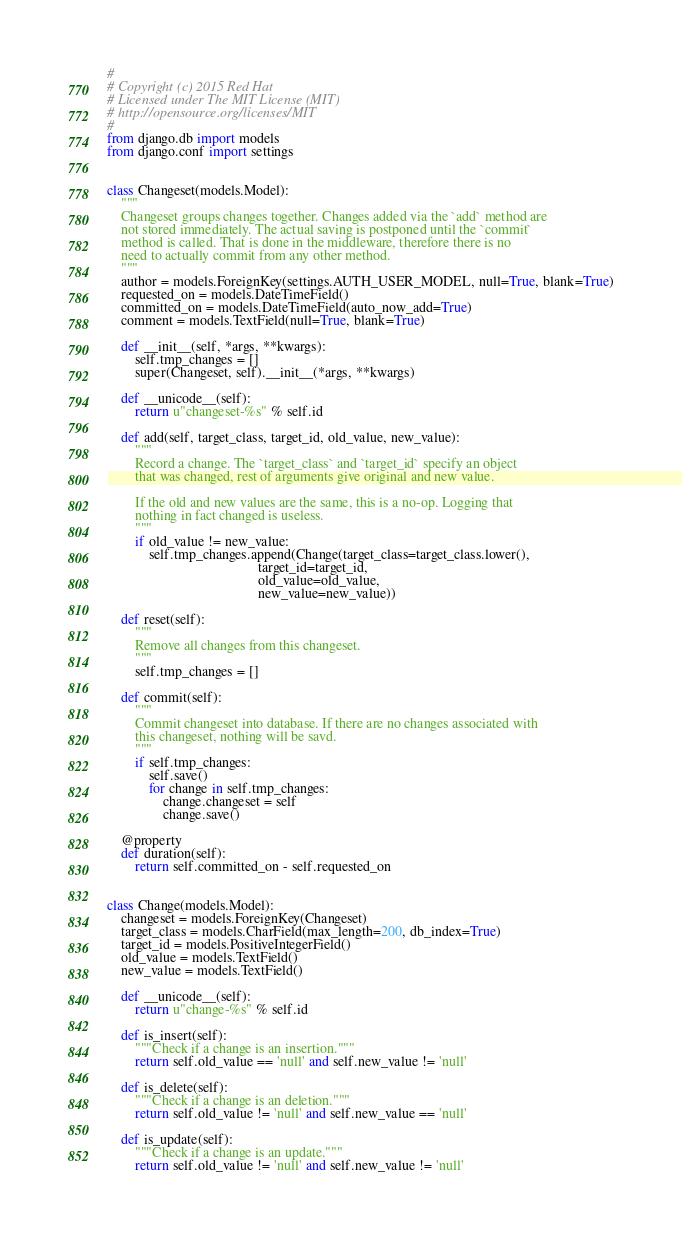<code> <loc_0><loc_0><loc_500><loc_500><_Python_>#
# Copyright (c) 2015 Red Hat
# Licensed under The MIT License (MIT)
# http://opensource.org/licenses/MIT
#
from django.db import models
from django.conf import settings


class Changeset(models.Model):
    """
    Changeset groups changes together. Changes added via the `add` method are
    not stored immediately. The actual saving is postponed until the `commit`
    method is called. That is done in the middleware, therefore there is no
    need to actually commit from any other method.
    """
    author = models.ForeignKey(settings.AUTH_USER_MODEL, null=True, blank=True)
    requested_on = models.DateTimeField()
    committed_on = models.DateTimeField(auto_now_add=True)
    comment = models.TextField(null=True, blank=True)

    def __init__(self, *args, **kwargs):
        self.tmp_changes = []
        super(Changeset, self).__init__(*args, **kwargs)

    def __unicode__(self):
        return u"changeset-%s" % self.id

    def add(self, target_class, target_id, old_value, new_value):
        """
        Record a change. The `target_class` and `target_id` specify an object
        that was changed, rest of arguments give original and new value.

        If the old and new values are the same, this is a no-op. Logging that
        nothing in fact changed is useless.
        """
        if old_value != new_value:
            self.tmp_changes.append(Change(target_class=target_class.lower(),
                                           target_id=target_id,
                                           old_value=old_value,
                                           new_value=new_value))

    def reset(self):
        """
        Remove all changes from this changeset.
        """
        self.tmp_changes = []

    def commit(self):
        """
        Commit changeset into database. If there are no changes associated with
        this changeset, nothing will be savd.
        """
        if self.tmp_changes:
            self.save()
            for change in self.tmp_changes:
                change.changeset = self
                change.save()

    @property
    def duration(self):
        return self.committed_on - self.requested_on


class Change(models.Model):
    changeset = models.ForeignKey(Changeset)
    target_class = models.CharField(max_length=200, db_index=True)
    target_id = models.PositiveIntegerField()
    old_value = models.TextField()
    new_value = models.TextField()

    def __unicode__(self):
        return u"change-%s" % self.id

    def is_insert(self):
        """Check if a change is an insertion."""
        return self.old_value == 'null' and self.new_value != 'null'

    def is_delete(self):
        """Check if a change is an deletion."""
        return self.old_value != 'null' and self.new_value == 'null'

    def is_update(self):
        """Check if a change is an update."""
        return self.old_value != 'null' and self.new_value != 'null'
</code> 